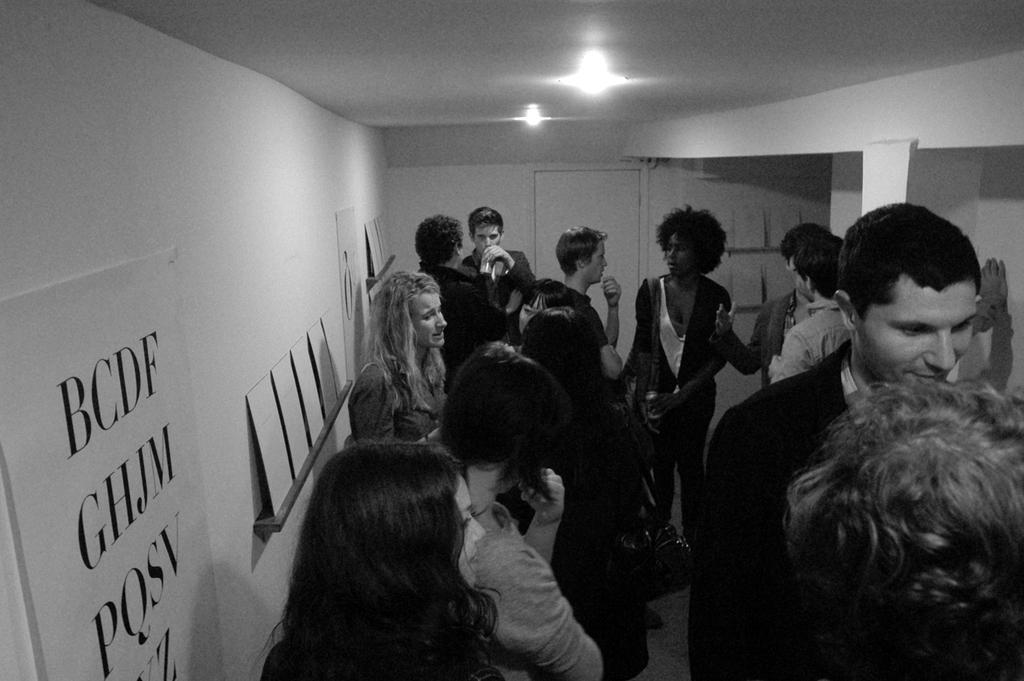How many people are in the image? There is a group of people in the image. What is the position of the people in the image? The people are standing on the floor. What can be seen on the wall in the image? There is a banner in the image. What is the background of the image? There are boards visible in the background of the image. What type of lighting is present in the image? There are lights in the image. What type of anger is the farmer expressing while playing in the band in the image? There is no farmer, band, or anger present in the image. 